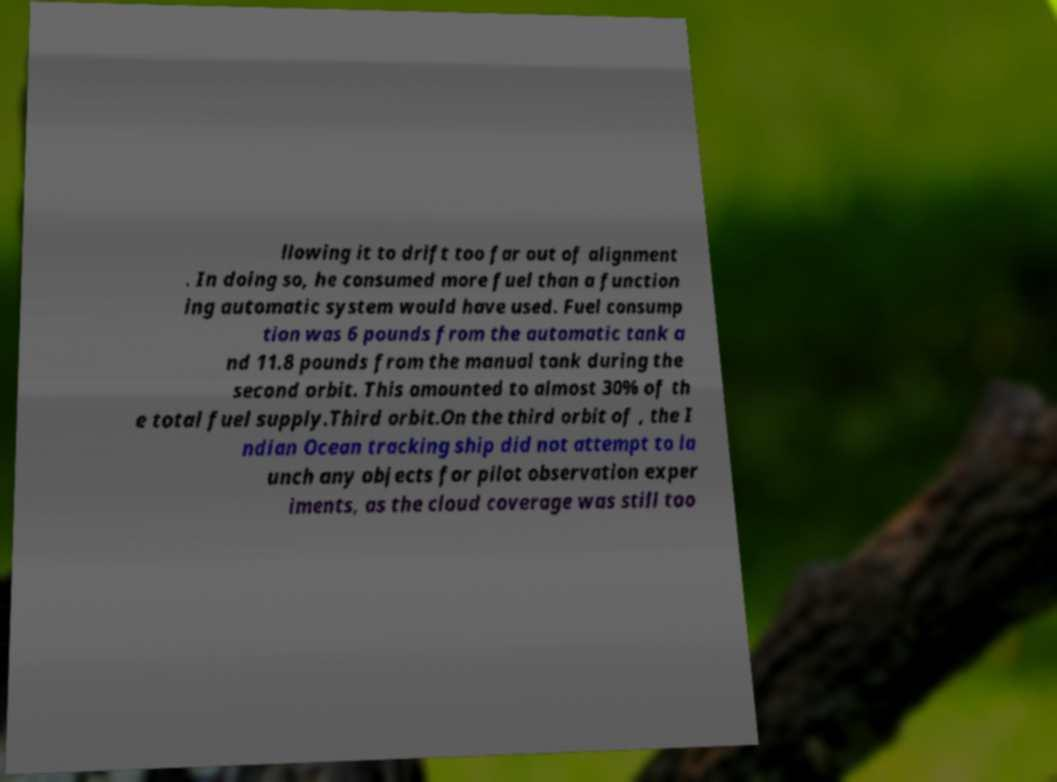I need the written content from this picture converted into text. Can you do that? llowing it to drift too far out of alignment . In doing so, he consumed more fuel than a function ing automatic system would have used. Fuel consump tion was 6 pounds from the automatic tank a nd 11.8 pounds from the manual tank during the second orbit. This amounted to almost 30% of th e total fuel supply.Third orbit.On the third orbit of , the I ndian Ocean tracking ship did not attempt to la unch any objects for pilot observation exper iments, as the cloud coverage was still too 